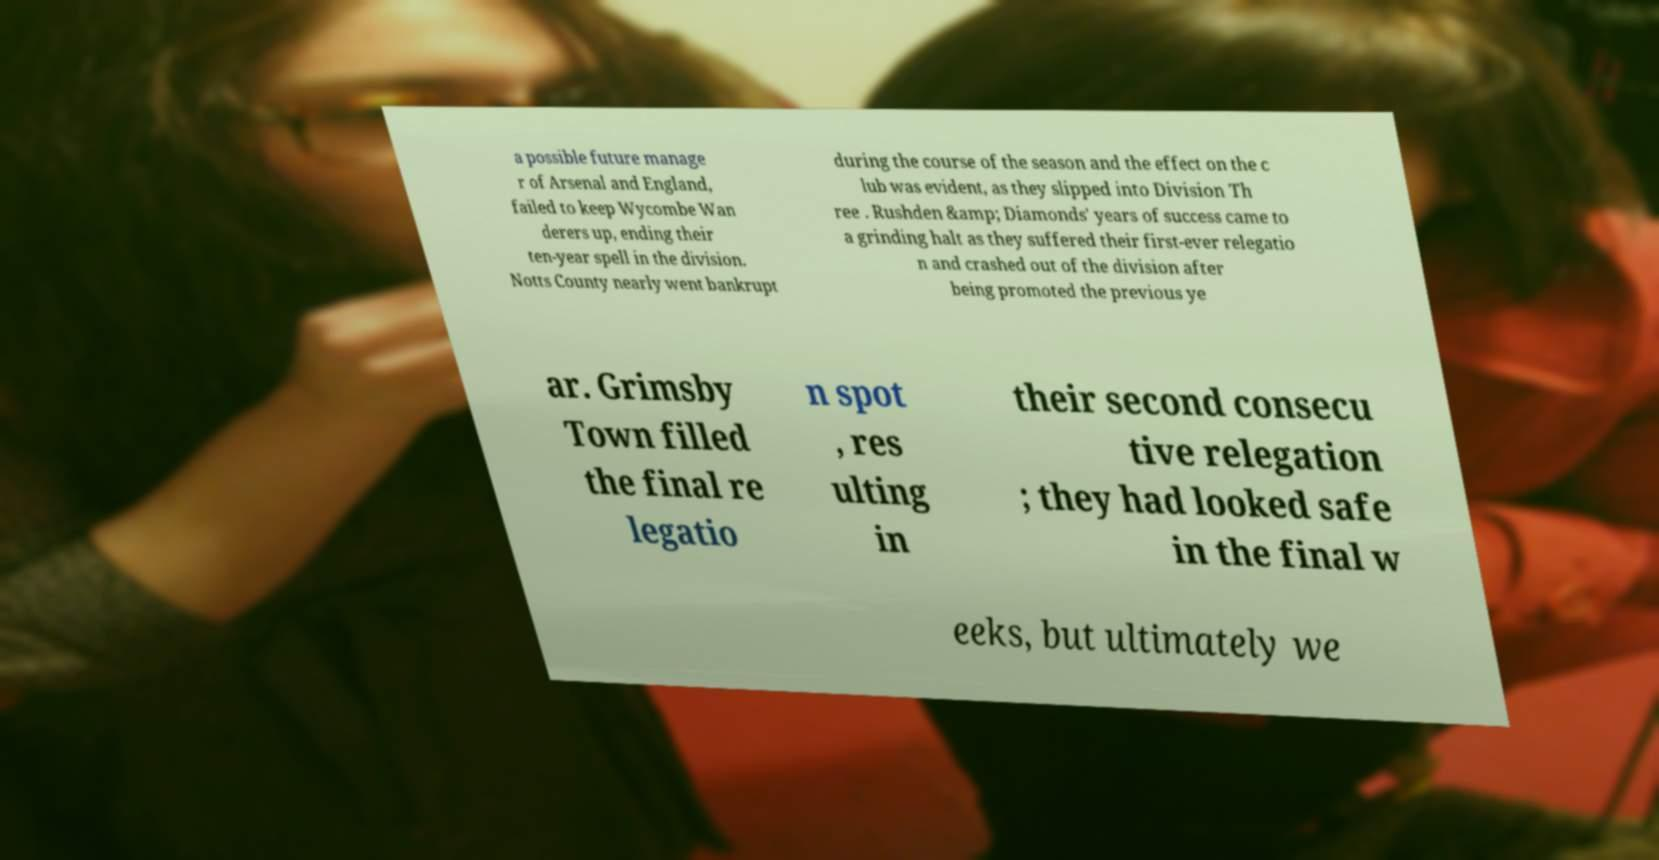I need the written content from this picture converted into text. Can you do that? a possible future manage r of Arsenal and England, failed to keep Wycombe Wan derers up, ending their ten-year spell in the division. Notts County nearly went bankrupt during the course of the season and the effect on the c lub was evident, as they slipped into Division Th ree . Rushden &amp; Diamonds' years of success came to a grinding halt as they suffered their first-ever relegatio n and crashed out of the division after being promoted the previous ye ar. Grimsby Town filled the final re legatio n spot , res ulting in their second consecu tive relegation ; they had looked safe in the final w eeks, but ultimately we 